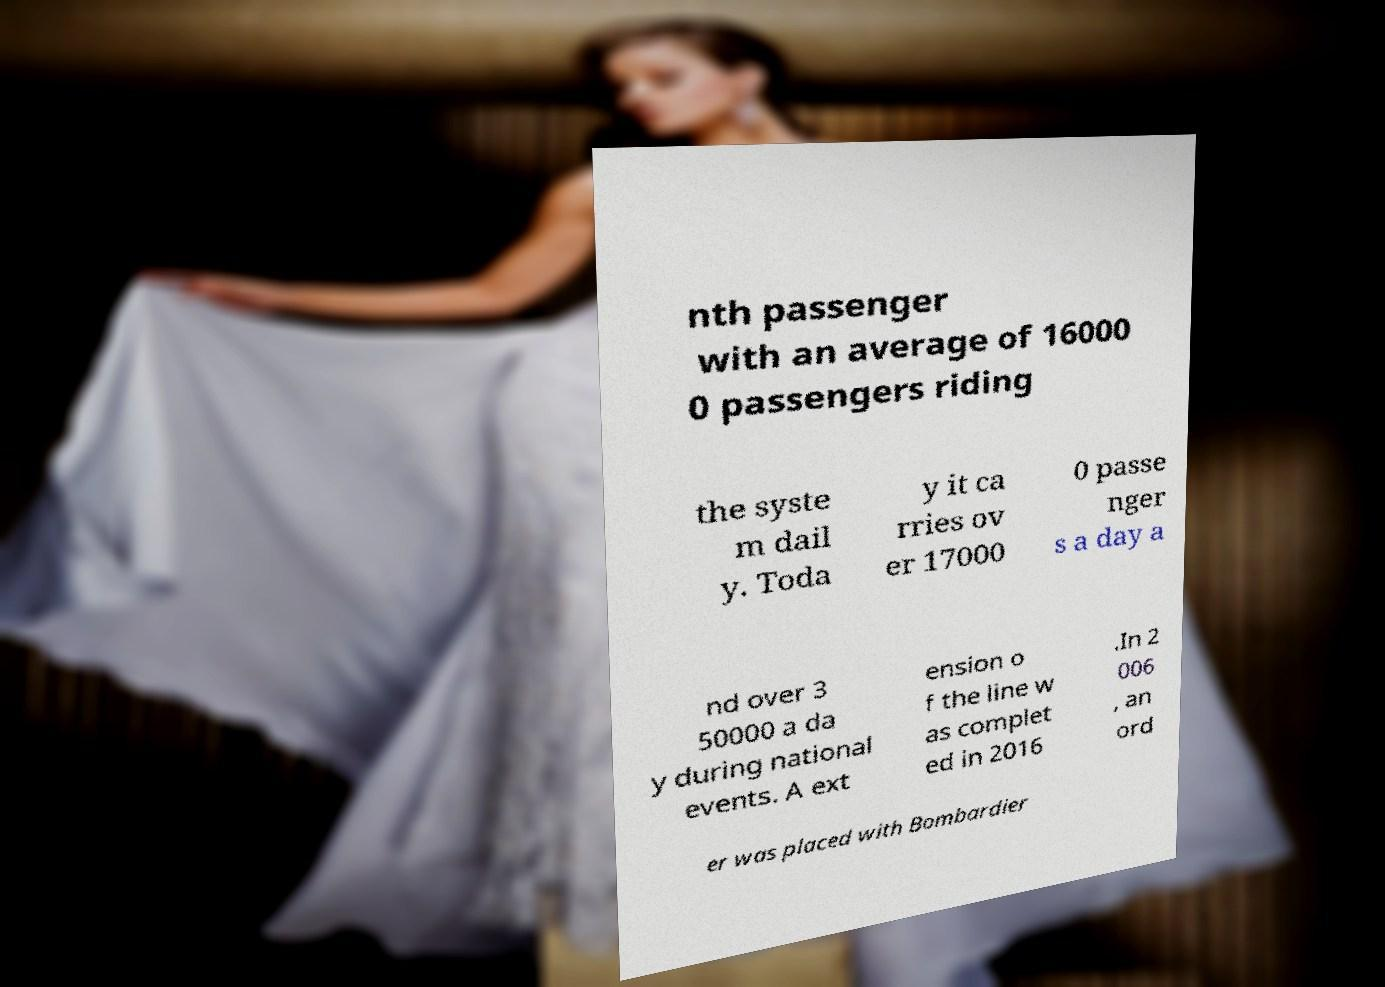For documentation purposes, I need the text within this image transcribed. Could you provide that? nth passenger with an average of 16000 0 passengers riding the syste m dail y. Toda y it ca rries ov er 17000 0 passe nger s a day a nd over 3 50000 a da y during national events. A ext ension o f the line w as complet ed in 2016 .In 2 006 , an ord er was placed with Bombardier 